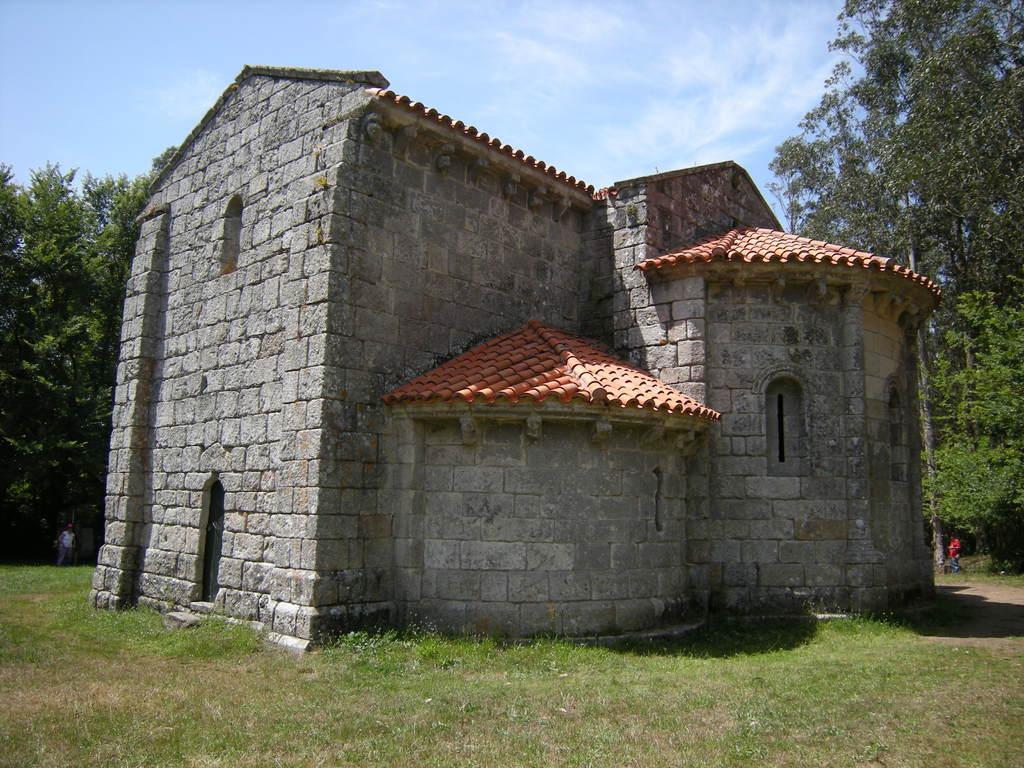Can you describe this image briefly? In this image we can see the stone house, lawn, a few people here, trees and the sky with clouds in the background. 